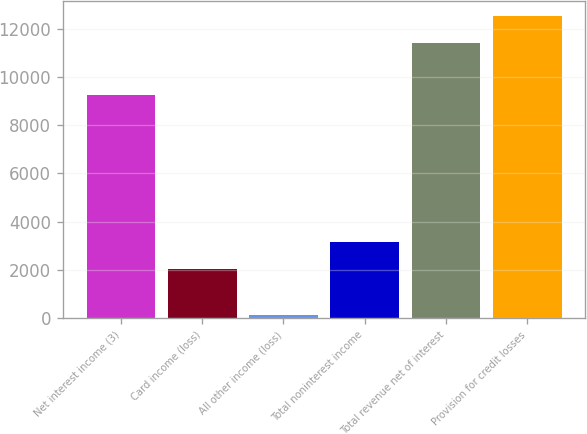<chart> <loc_0><loc_0><loc_500><loc_500><bar_chart><fcel>Net interest income (3)<fcel>Card income (loss)<fcel>All other income (loss)<fcel>Total noninterest income<fcel>Total revenue net of interest<fcel>Provision for credit losses<nl><fcel>9250<fcel>2034<fcel>115<fcel>3162.4<fcel>11399<fcel>12527.4<nl></chart> 